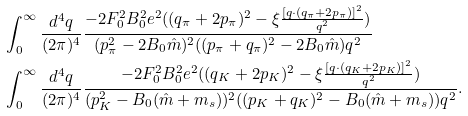Convert formula to latex. <formula><loc_0><loc_0><loc_500><loc_500>& \int _ { 0 } ^ { \infty } \frac { d ^ { 4 } q } { ( 2 \pi ) ^ { 4 } } \frac { - 2 F _ { 0 } ^ { 2 } B _ { 0 } ^ { 2 } e ^ { 2 } ( ( q _ { \pi } + 2 p _ { \pi } ) ^ { 2 } - \xi \frac { [ q \cdot ( q _ { \pi } + 2 p _ { \pi } ) ] ^ { 2 } } { q ^ { 2 } } ) } { ( p ^ { 2 } _ { \pi } - 2 B _ { 0 } \hat { m } ) ^ { 2 } ( ( p _ { \pi } + q _ { \pi } ) ^ { 2 } - 2 B _ { 0 } \hat { m } ) q ^ { 2 } } \\ & \int _ { 0 } ^ { \infty } \frac { d ^ { 4 } q } { ( 2 \pi ) ^ { 4 } } \frac { - 2 F _ { 0 } ^ { 2 } B _ { 0 } ^ { 2 } e ^ { 2 } ( ( q _ { K } + 2 p _ { K } ) ^ { 2 } - \xi \frac { [ q \cdot ( q _ { K } + 2 p _ { K } ) ] ^ { 2 } } { q ^ { 2 } } ) } { ( p ^ { 2 } _ { K } - B _ { 0 } ( \hat { m } + m _ { s } ) ) ^ { 2 } ( ( p _ { K } + q _ { K } ) ^ { 2 } - B _ { 0 } ( \hat { m } + m _ { s } ) ) q ^ { 2 } } .</formula> 